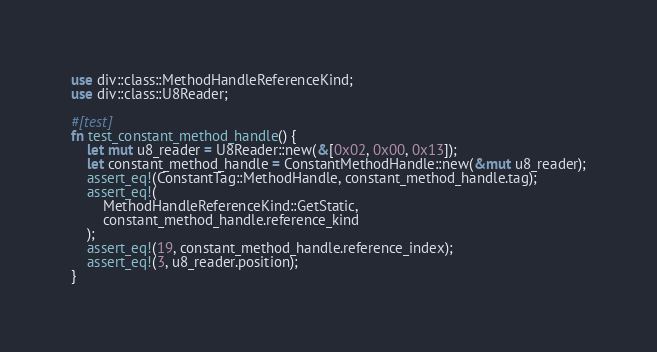Convert code to text. <code><loc_0><loc_0><loc_500><loc_500><_Rust_>use div::class::MethodHandleReferenceKind;
use div::class::U8Reader;

#[test]
fn test_constant_method_handle() {
    let mut u8_reader = U8Reader::new(&[0x02, 0x00, 0x13]);
    let constant_method_handle = ConstantMethodHandle::new(&mut u8_reader);
    assert_eq!(ConstantTag::MethodHandle, constant_method_handle.tag);
    assert_eq!(
        MethodHandleReferenceKind::GetStatic,
        constant_method_handle.reference_kind
    );
    assert_eq!(19, constant_method_handle.reference_index);
    assert_eq!(3, u8_reader.position);
}
</code> 